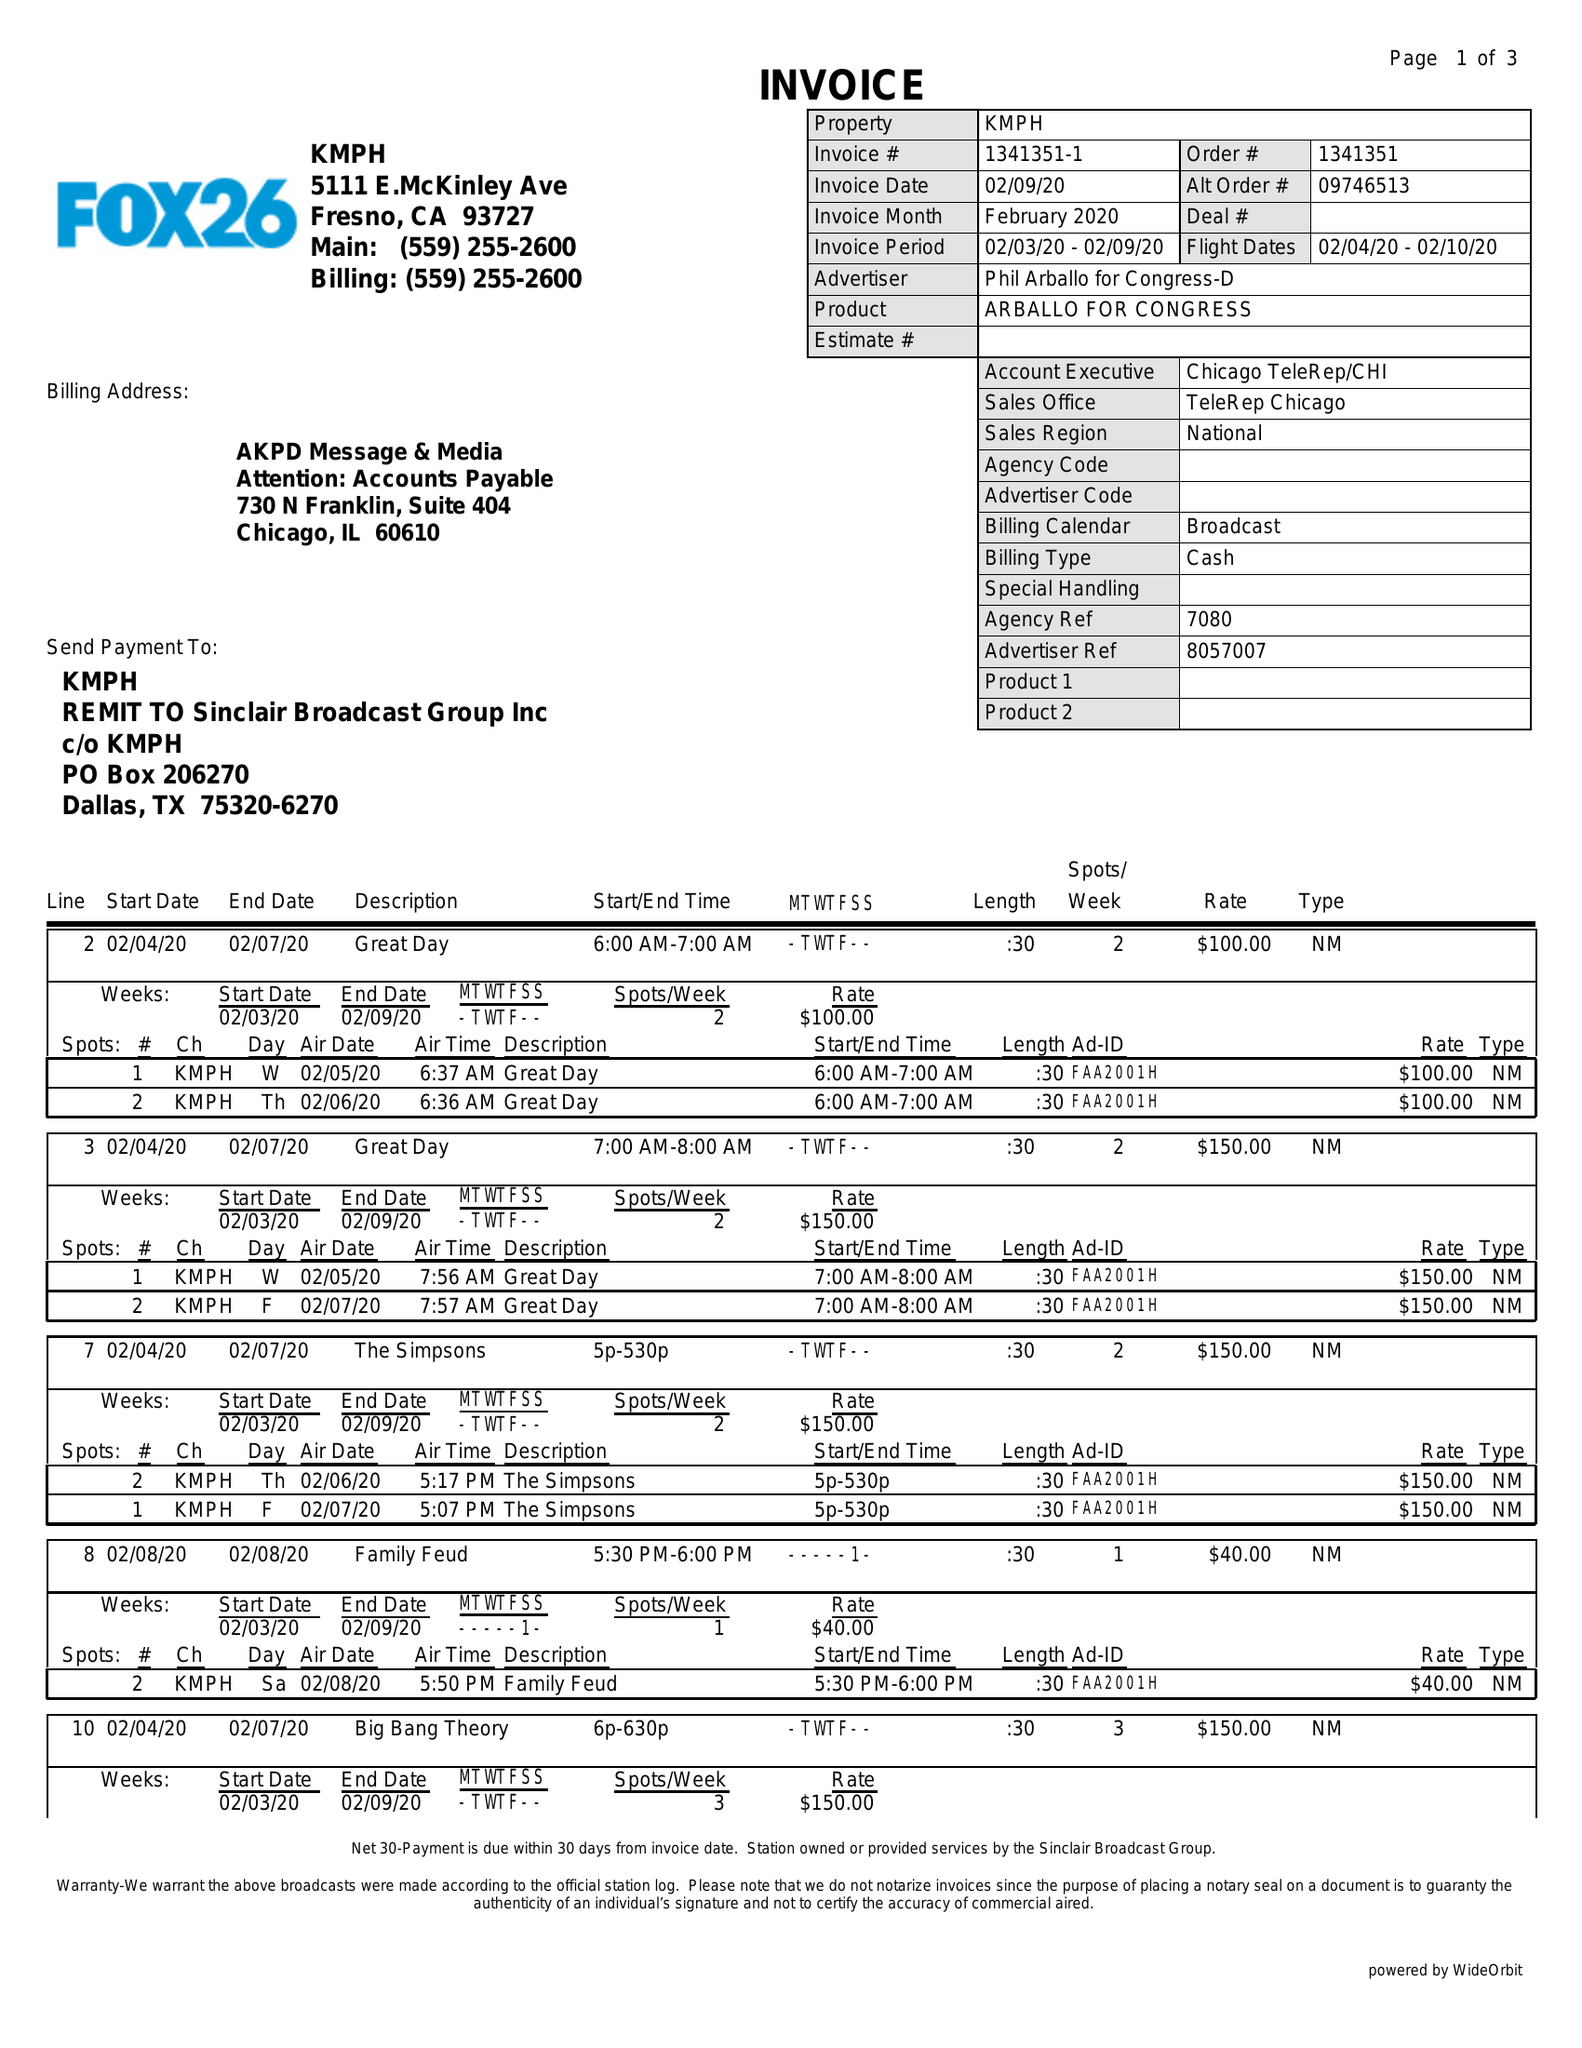What is the value for the gross_amount?
Answer the question using a single word or phrase. 8780.00 